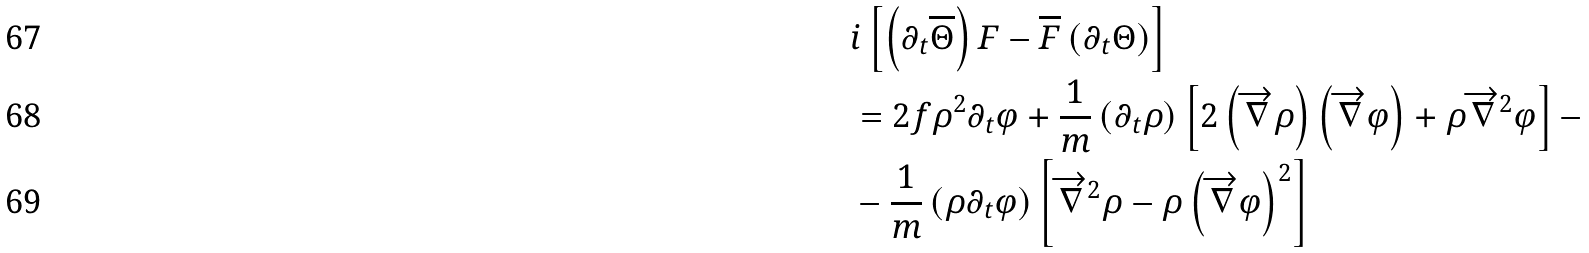<formula> <loc_0><loc_0><loc_500><loc_500>& i \left [ \left ( \partial _ { t } \overline { \Theta } \right ) F - \overline { F } \left ( \partial _ { t } \Theta \right ) \right ] \\ & = 2 f \rho ^ { 2 } \partial _ { t } \varphi + \frac { 1 } { m } \left ( \partial _ { t } \rho \right ) \left [ 2 \left ( \overrightarrow { \nabla } \rho \right ) \left ( \overrightarrow { \nabla } \varphi \right ) + \rho \overrightarrow { \nabla } ^ { 2 } \varphi \right ] - \\ & - \frac { 1 } { m } \left ( \rho \partial _ { t } \varphi \right ) \left [ \overrightarrow { \nabla } ^ { 2 } \rho - \rho \left ( \overrightarrow { \nabla } \varphi \right ) ^ { 2 } \right ]</formula> 